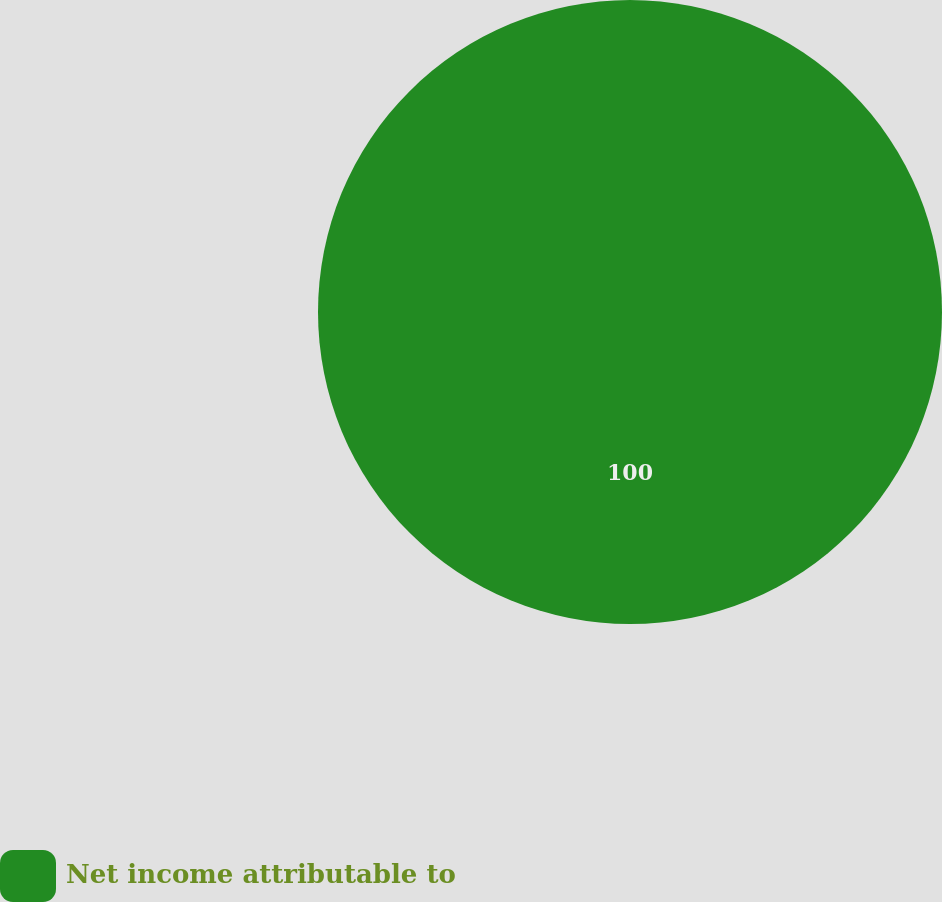<chart> <loc_0><loc_0><loc_500><loc_500><pie_chart><fcel>Net income attributable to<nl><fcel>100.0%<nl></chart> 